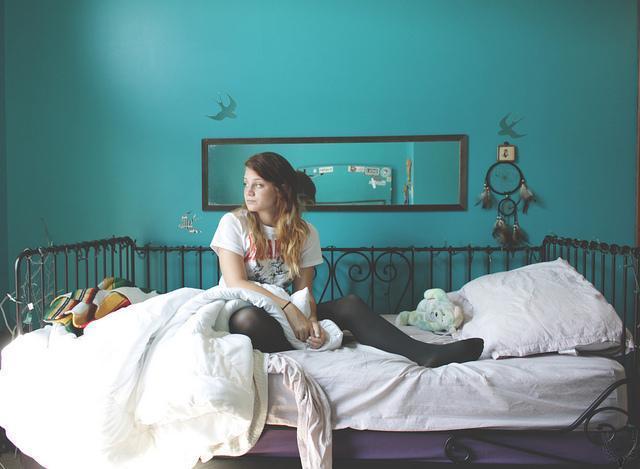How many giraffes are looking straight at the camera?
Give a very brief answer. 0. 